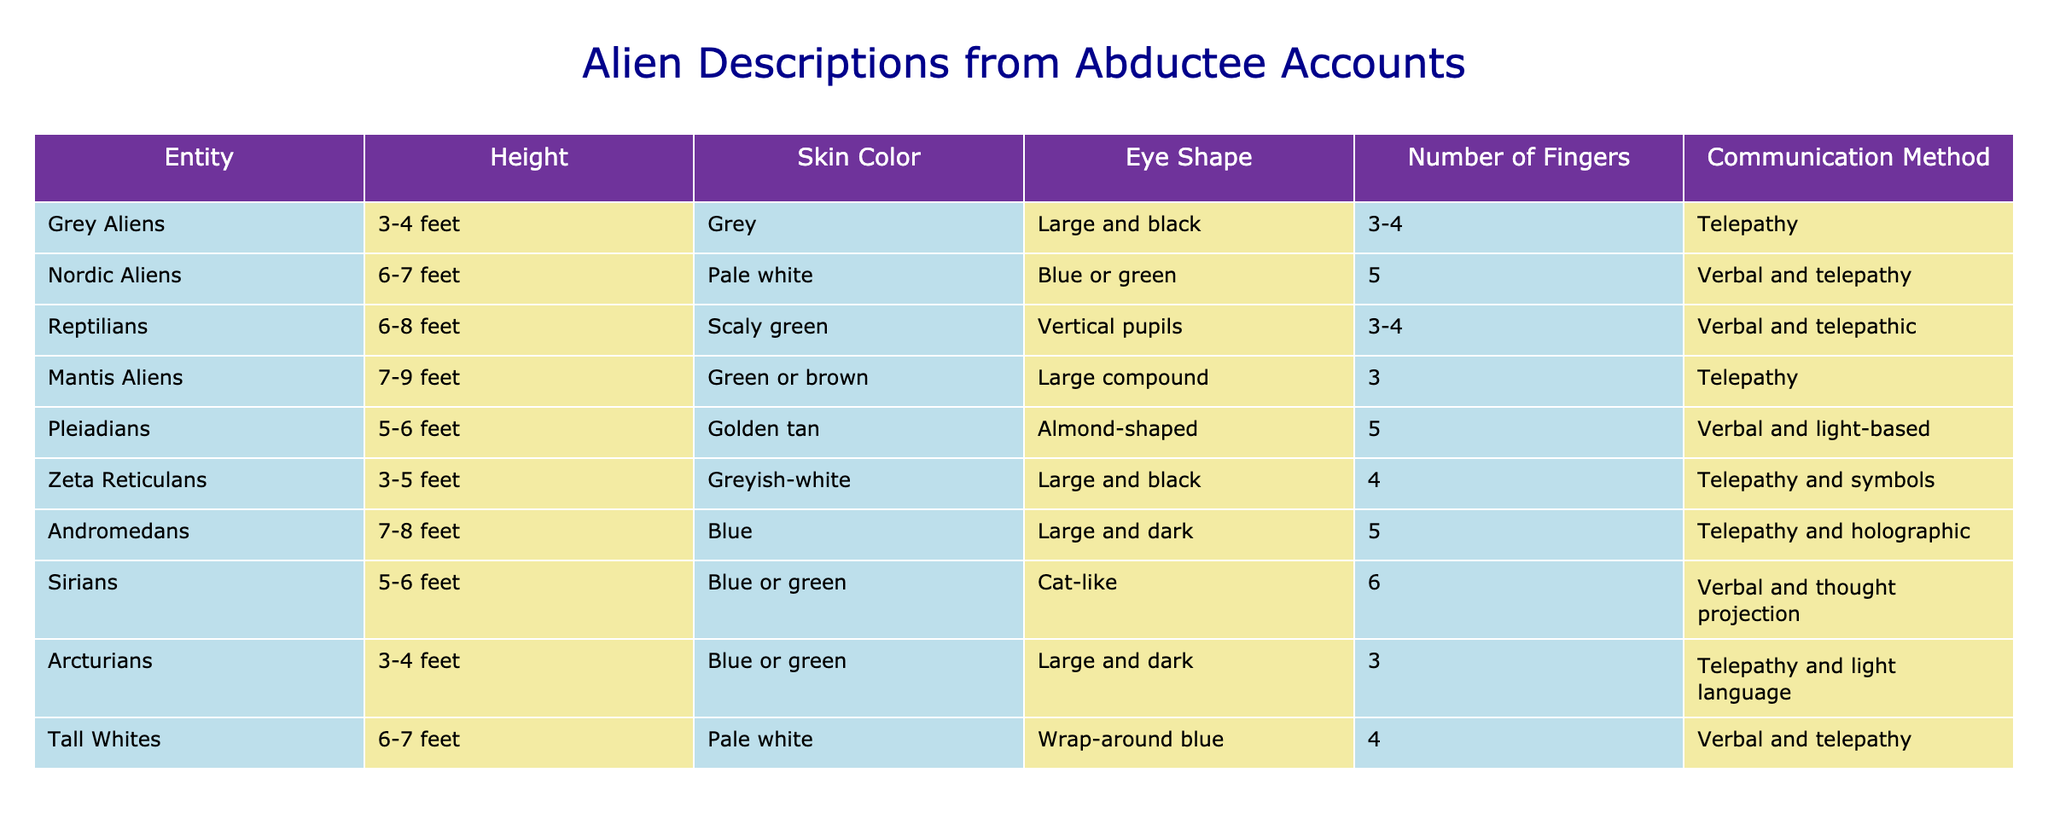What is the height range of Grey Aliens? From the table, Grey Aliens have a height range specified as 3-4 feet. This value can be directly found in the "Height" column for Grey Aliens.
Answer: 3-4 feet Which entities communicate using telepathy? By examining the "Communication Method" column, Grey Aliens, Mantis Aliens, Zeta Reticulans, Arcturians, and Andromedans are listed as communicating through telepathy. These are directly obtained by listing each entity's communication method.
Answer: Grey Aliens, Mantis Aliens, Zeta Reticulans, Arcturians, Andromedans How many fingers do the Reptilians have? The "Number of Fingers" column indicates that Reptilians have 3-4 fingers. This can be found by looking specifically at the row corresponding to Reptilians in the table.
Answer: 3-4 Is there an alien mentioned that has blue or green skin? According to the "Skin Color" column, the entities Nordic Aliens, Reptilians, Sirians, and Arcturians are noted to have blue or green skin, confirming the query. Each alien's skin color is easily found in their respective rows.
Answer: Yes What is the average height of entities listed in the table? To find the average height, we convert all the height ranges into numerical values: Grey Aliens (3.5), Nordic Aliens (6.5), Reptilians (7), Mantis Aliens (8), Pleiadians (5.5), Zeta Reticulans (4), Andromedans (7.5), Sirians (5.5), Arcturians (3.5), and Tall Whites (6.5). Adding these gives a total height of 58.5. There are 10 entities, so the average height is 58.5/10 = 5.85 feet.
Answer: 5.85 feet How many entities are classified as having vertical pupils? By checking the "Eye Shape" column, only Reptilians are noted to have vertical pupils. This is a straightforward retrieval of data from the table.
Answer: 1 